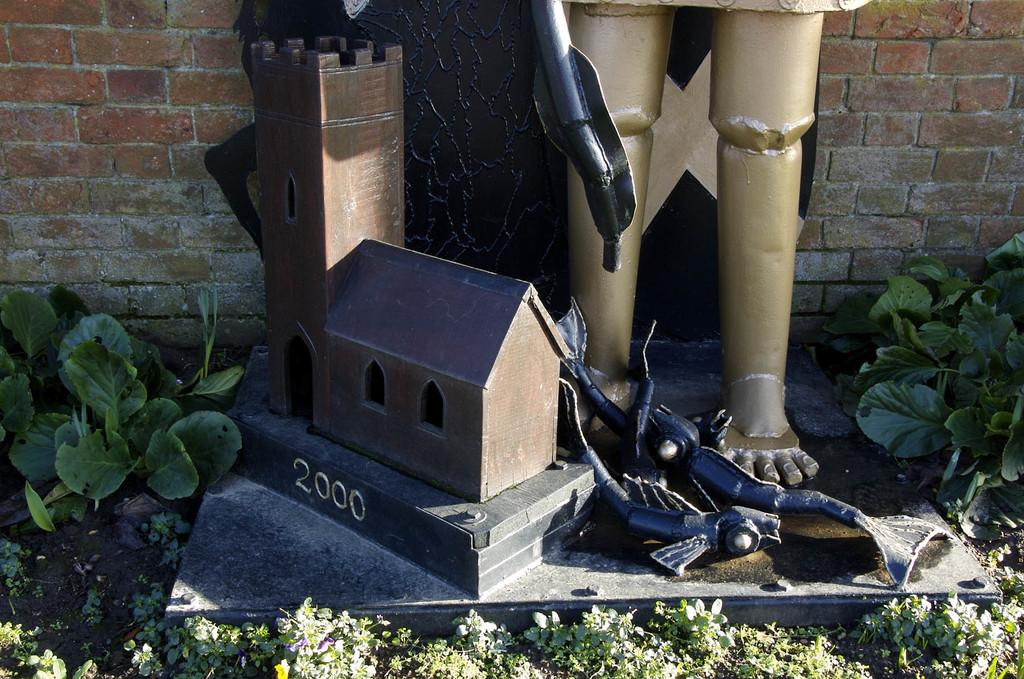What is located on the ground in the image? There is a sculpture on the ground in the image. What can be seen in the background of the image? There are walls and plants in the background of the image. How many times has the sculpture been folded in the image? The sculpture cannot be folded, as it is a solid object in the image. Is there any evidence of an earthquake in the image? There is no indication of an earthquake in the image; the sculpture and surrounding environment appear stable. 